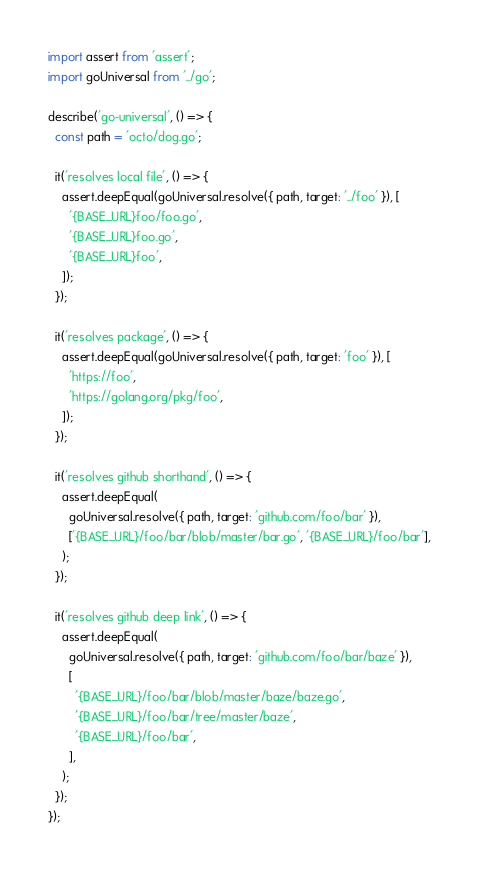<code> <loc_0><loc_0><loc_500><loc_500><_JavaScript_>import assert from 'assert';
import goUniversal from '../go';

describe('go-universal', () => {
  const path = 'octo/dog.go';

  it('resolves local file', () => {
    assert.deepEqual(goUniversal.resolve({ path, target: '../foo' }), [
      '{BASE_URL}foo/foo.go',
      '{BASE_URL}foo.go',
      '{BASE_URL}foo',
    ]);
  });

  it('resolves package', () => {
    assert.deepEqual(goUniversal.resolve({ path, target: 'foo' }), [
      'https://foo',
      'https://golang.org/pkg/foo',
    ]);
  });

  it('resolves github shorthand', () => {
    assert.deepEqual(
      goUniversal.resolve({ path, target: 'github.com/foo/bar' }),
      ['{BASE_URL}/foo/bar/blob/master/bar.go', '{BASE_URL}/foo/bar'],
    );
  });

  it('resolves github deep link', () => {
    assert.deepEqual(
      goUniversal.resolve({ path, target: 'github.com/foo/bar/baze' }),
      [
        '{BASE_URL}/foo/bar/blob/master/baze/baze.go',
        '{BASE_URL}/foo/bar/tree/master/baze',
        '{BASE_URL}/foo/bar',
      ],
    );
  });
});
</code> 